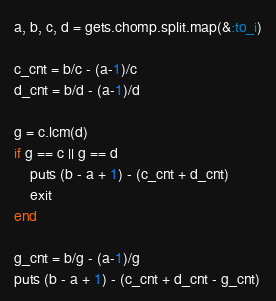<code> <loc_0><loc_0><loc_500><loc_500><_Ruby_>a, b, c, d = gets.chomp.split.map(&:to_i)

c_cnt = b/c - (a-1)/c
d_cnt = b/d - (a-1)/d

g = c.lcm(d)
if g == c || g == d
    puts (b - a + 1) - (c_cnt + d_cnt)
    exit
end

g_cnt = b/g - (a-1)/g
puts (b - a + 1) - (c_cnt + d_cnt - g_cnt)
</code> 